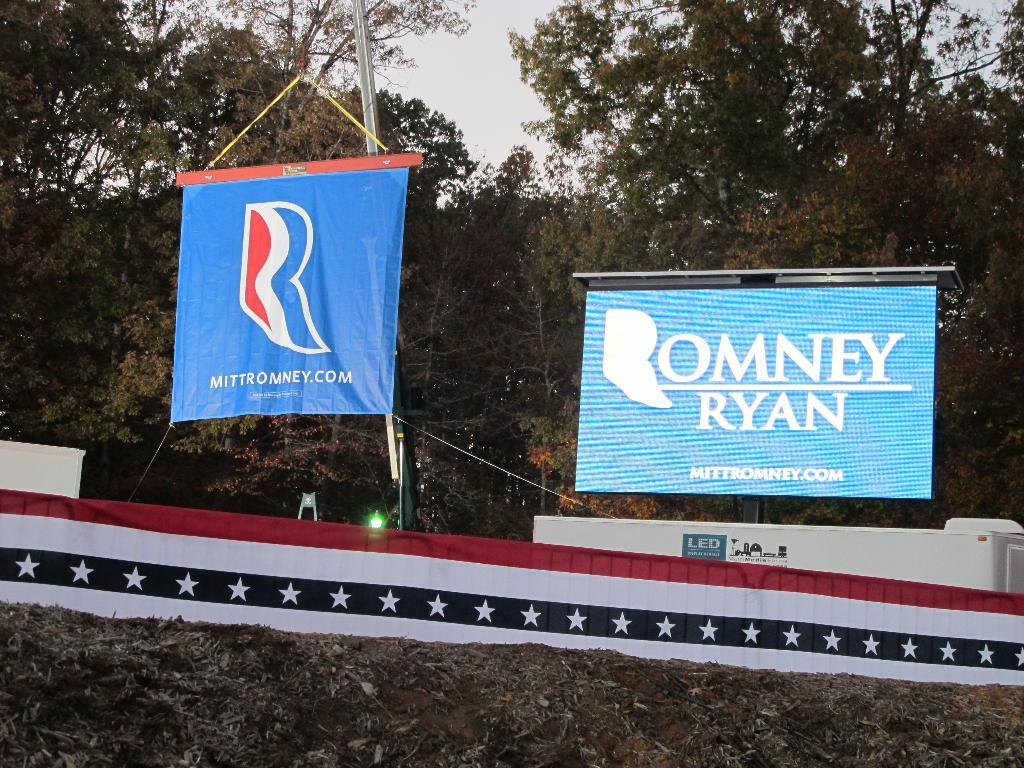<image>
Describe the image concisely. Large blue outdoor billboards reading Romney and Ryan. 